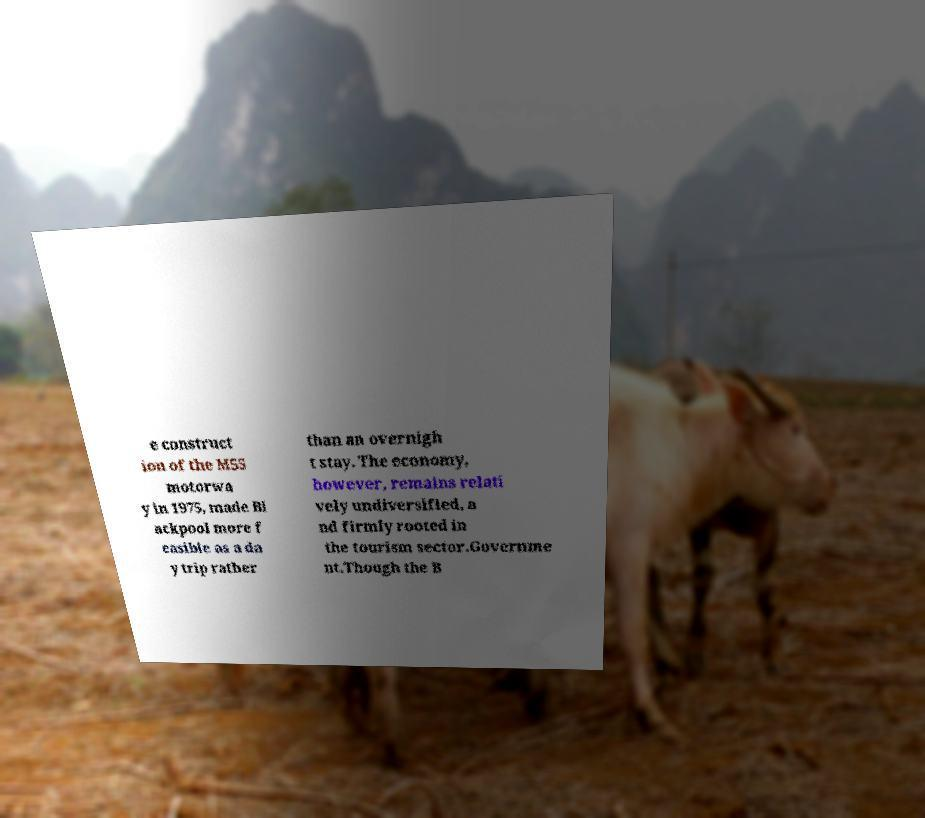Can you read and provide the text displayed in the image?This photo seems to have some interesting text. Can you extract and type it out for me? e construct ion of the M55 motorwa y in 1975, made Bl ackpool more f easible as a da y trip rather than an overnigh t stay. The economy, however, remains relati vely undiversified, a nd firmly rooted in the tourism sector.Governme nt.Though the B 